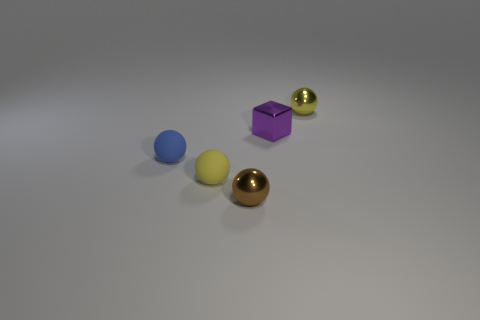Add 3 tiny red cylinders. How many objects exist? 8 Subtract all spheres. How many objects are left? 1 Add 4 shiny things. How many shiny things are left? 7 Add 1 blue balls. How many blue balls exist? 2 Subtract 0 cyan balls. How many objects are left? 5 Subtract all tiny yellow matte things. Subtract all rubber spheres. How many objects are left? 2 